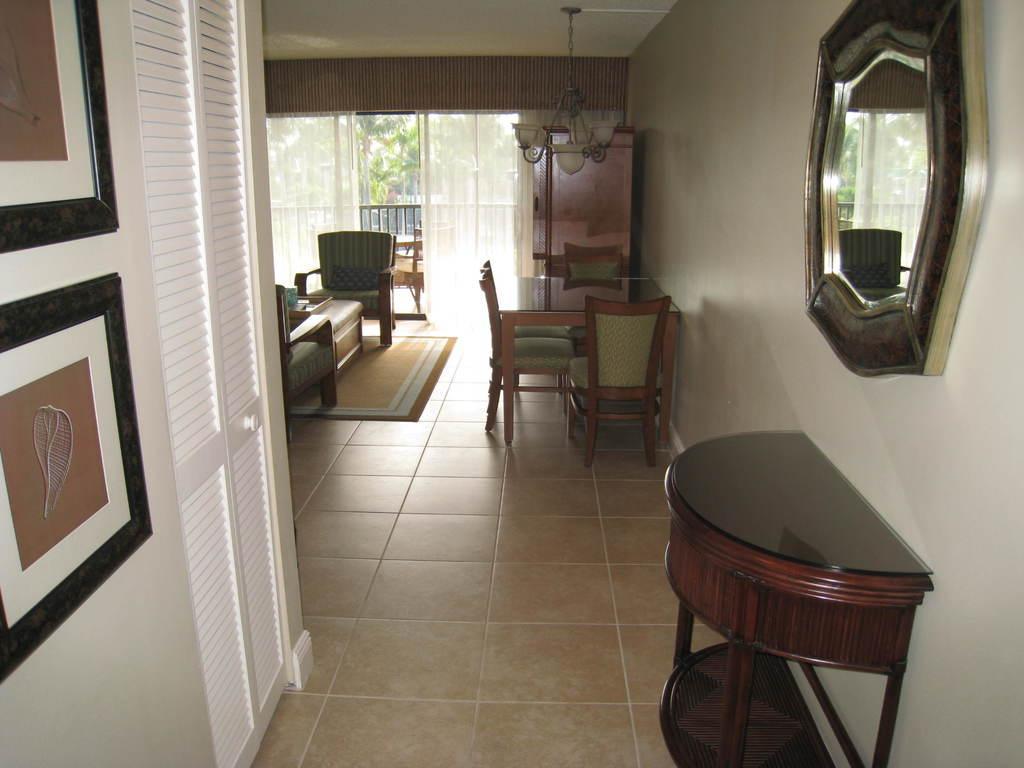Please provide a concise description of this image. In this image we can see table, chairs, mirror, lights, door, photo frames, curtains, mats and trees. 